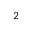Convert formula to latex. <formula><loc_0><loc_0><loc_500><loc_500>^ { 2 }</formula> 